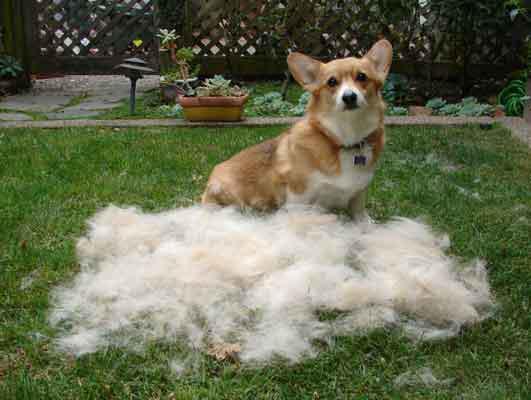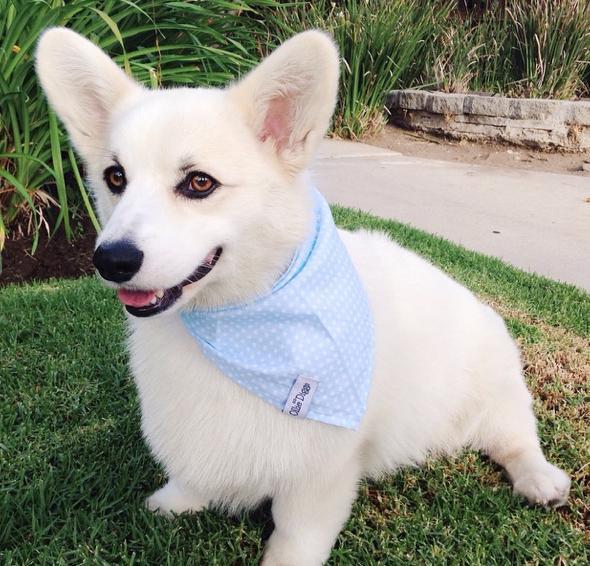The first image is the image on the left, the second image is the image on the right. Examine the images to the left and right. Is the description "The dog in the image on the right has its mouth open." accurate? Answer yes or no. Yes. The first image is the image on the left, the second image is the image on the right. Analyze the images presented: Is the assertion "The left image shows a corgi sitting on green grass behind a mound of pale dog fir." valid? Answer yes or no. Yes. 